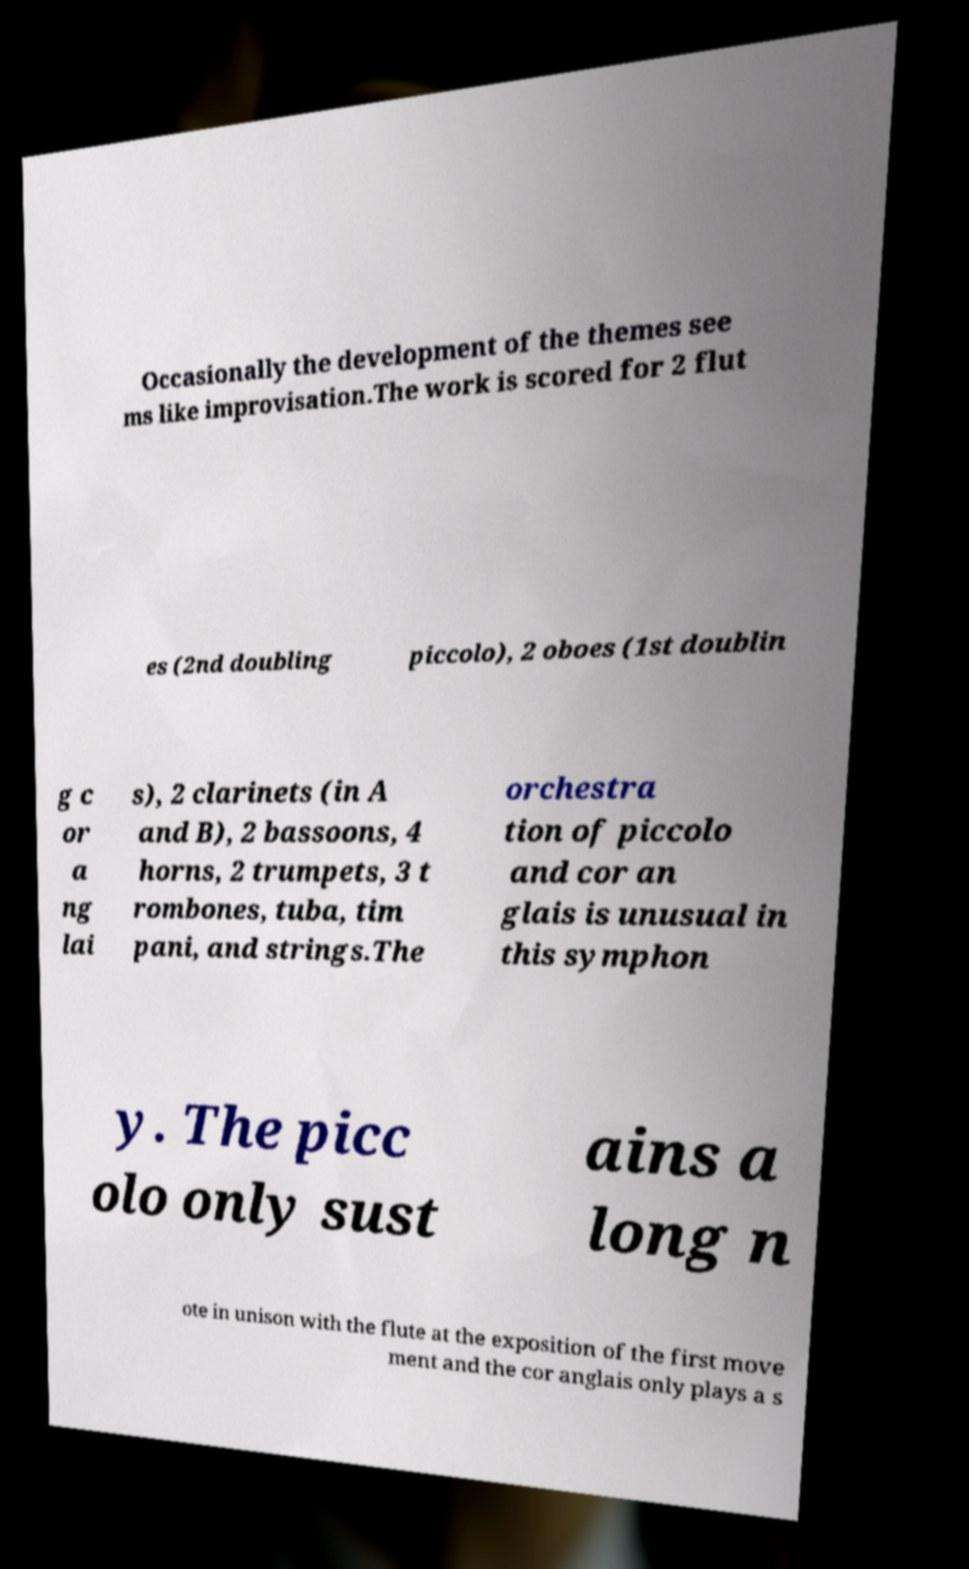What messages or text are displayed in this image? I need them in a readable, typed format. Occasionally the development of the themes see ms like improvisation.The work is scored for 2 flut es (2nd doubling piccolo), 2 oboes (1st doublin g c or a ng lai s), 2 clarinets (in A and B), 2 bassoons, 4 horns, 2 trumpets, 3 t rombones, tuba, tim pani, and strings.The orchestra tion of piccolo and cor an glais is unusual in this symphon y. The picc olo only sust ains a long n ote in unison with the flute at the exposition of the first move ment and the cor anglais only plays a s 